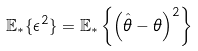Convert formula to latex. <formula><loc_0><loc_0><loc_500><loc_500>\mathbb { E } _ { \ast } \{ \epsilon ^ { 2 } \} = \mathbb { E } _ { \ast } \left \{ \left ( \hat { \theta } - \theta \right ) ^ { 2 } \right \}</formula> 